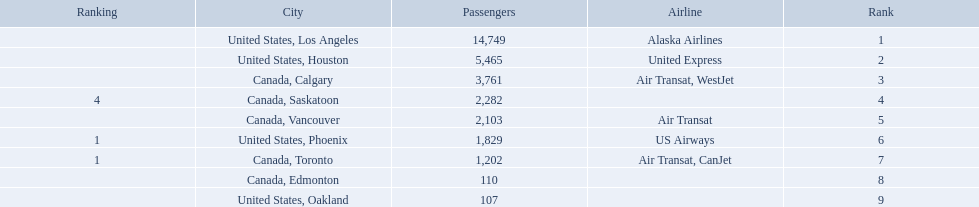What are the cities flown to? United States, Los Angeles, United States, Houston, Canada, Calgary, Canada, Saskatoon, Canada, Vancouver, United States, Phoenix, Canada, Toronto, Canada, Edmonton, United States, Oakland. What number of passengers did pheonix have? 1,829. 